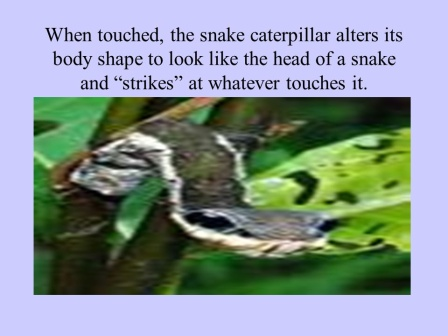Imagine a world where the caterpillar’s mimicry goes beyond just looking like a snake. Describe what further evolutionary adaptations might occur. Imagine a future where the snake caterpillar's mimicry has evolved even further. In this scenario, the caterpillar is not only capable of visually mimicking a snake but can also make convincing snake-like hissing sounds, adding an auditory component to its defensive arsenal. Additionally, it might evolve the ability to produce a faint rattling sound by vibrating its body, similar to a rattlesnake. The texture of its skin could change to be rougher, increasing the tactile similarity to a snake's scales. This multi-sensory mimicry would greatly enhance its chances of deterring predators, making it one of the most formidable imitators in the animal kingdom. In a fictional story, how would humans react to encountering such a highly evolved caterpillar? In a fictional tale, humans encountering this highly evolved caterpillar would likely react with a mixture of awe and fear. Initially, the caterpillar might be mistaken for a real snake, causing alarm and caution. Upon realizing it’s an insect, scientists would be deeply intrigued, sparking a wave of research and media interest. This discovery could reveal new insights into evolutionary biology and animal behavior, drawing global attention. Enthusiasts from various fields, including entomologists, biologists, and even artists, might flock to study and depict this extraordinary creature, cementing its place as a symbol of nature's ingenuity and adaptability. 